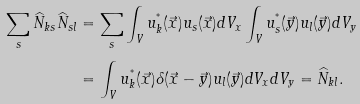Convert formula to latex. <formula><loc_0><loc_0><loc_500><loc_500>\sum _ { s } \widehat { N } _ { k s } \widehat { N } _ { s l } & = \sum _ { s } \int _ { V } u _ { k } ^ { ^ { * } } ( \vec { x } ) u _ { s } ( \vec { x } ) d V _ { x } \int _ { V } u _ { s } ^ { ^ { * } } ( \vec { y } ) u _ { l } ( \vec { y } ) d V _ { y } \\ & = \int _ { V } u _ { k } ^ { ^ { * } } ( \vec { x } ) \delta ( \vec { x } - \vec { y } ) u _ { l } ( \vec { y } ) d V _ { x } d V _ { y } = \widehat { N } _ { k l } .</formula> 